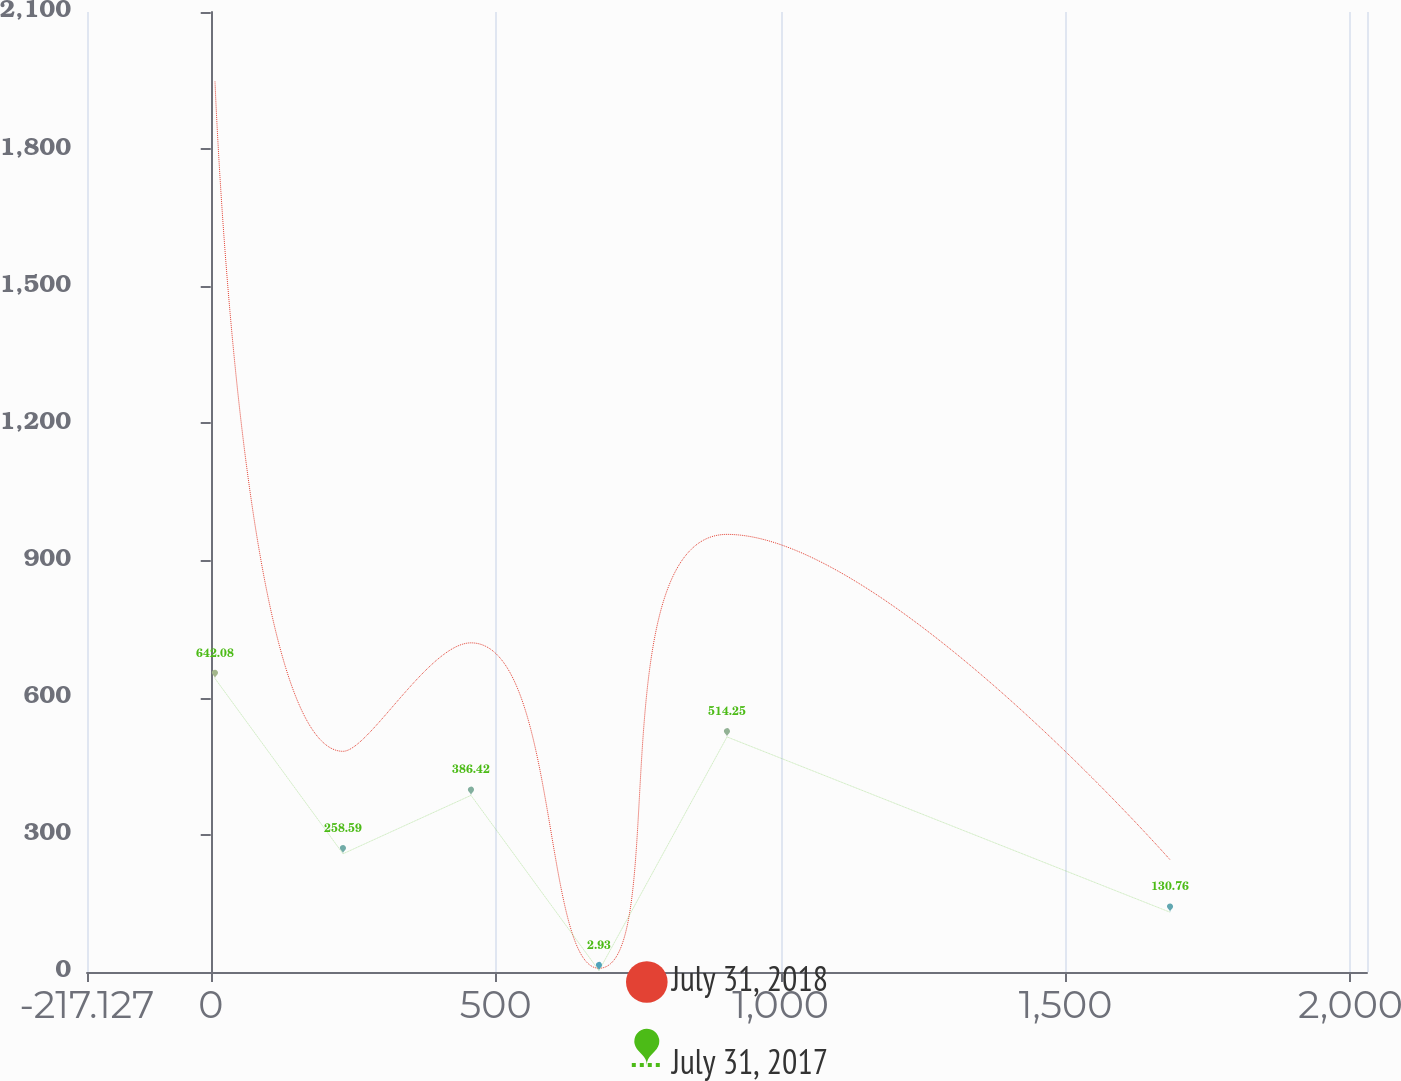Convert chart to OTSL. <chart><loc_0><loc_0><loc_500><loc_500><line_chart><ecel><fcel>July 31, 2018<fcel>July 31, 2017<nl><fcel>7.49<fcel>1948.03<fcel>642.08<nl><fcel>232.11<fcel>482.75<fcel>258.59<nl><fcel>456.73<fcel>720.02<fcel>386.42<nl><fcel>681.35<fcel>8.2<fcel>2.93<nl><fcel>905.97<fcel>957.29<fcel>514.25<nl><fcel>1683.48<fcel>245.47<fcel>130.76<nl><fcel>2253.66<fcel>2380.95<fcel>1281.19<nl></chart> 